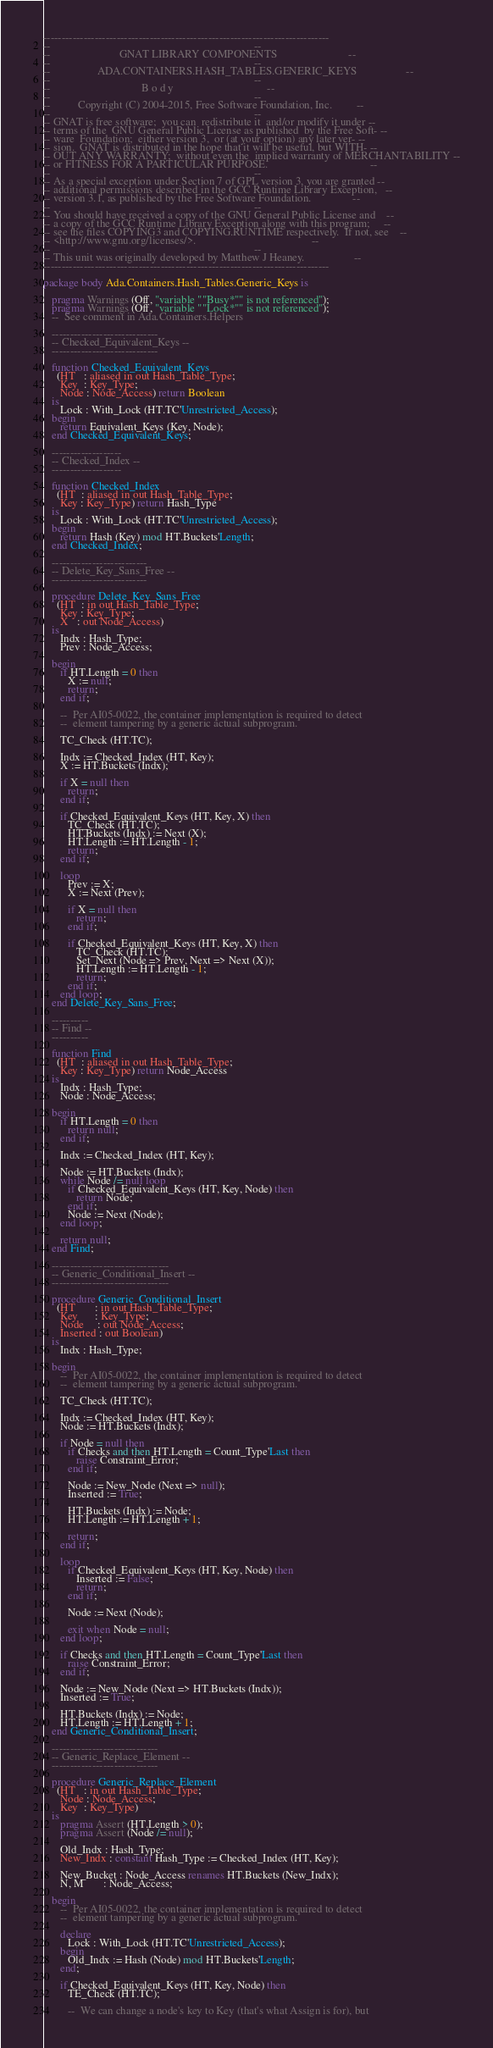Convert code to text. <code><loc_0><loc_0><loc_500><loc_500><_Ada_>------------------------------------------------------------------------------
--                                                                          --
--                         GNAT LIBRARY COMPONENTS                          --
--                                                                          --
--                 ADA.CONTAINERS.HASH_TABLES.GENERIC_KEYS                  --
--                                                                          --
--                                 B o d y                                  --
--                                                                          --
--          Copyright (C) 2004-2015, Free Software Foundation, Inc.         --
--                                                                          --
-- GNAT is free software;  you can  redistribute it  and/or modify it under --
-- terms of the  GNU General Public License as published  by the Free Soft- --
-- ware  Foundation;  either version 3,  or (at your option) any later ver- --
-- sion.  GNAT is distributed in the hope that it will be useful, but WITH- --
-- OUT ANY WARRANTY;  without even the  implied warranty of MERCHANTABILITY --
-- or FITNESS FOR A PARTICULAR PURPOSE.                                     --
--                                                                          --
-- As a special exception under Section 7 of GPL version 3, you are granted --
-- additional permissions described in the GCC Runtime Library Exception,   --
-- version 3.1, as published by the Free Software Foundation.               --
--                                                                          --
-- You should have received a copy of the GNU General Public License and    --
-- a copy of the GCC Runtime Library Exception along with this program;     --
-- see the files COPYING3 and COPYING.RUNTIME respectively.  If not, see    --
-- <http://www.gnu.org/licenses/>.                                          --
--                                                                          --
-- This unit was originally developed by Matthew J Heaney.                  --
------------------------------------------------------------------------------

package body Ada.Containers.Hash_Tables.Generic_Keys is

   pragma Warnings (Off, "variable ""Busy*"" is not referenced");
   pragma Warnings (Off, "variable ""Lock*"" is not referenced");
   --  See comment in Ada.Containers.Helpers

   -----------------------------
   -- Checked_Equivalent_Keys --
   -----------------------------

   function Checked_Equivalent_Keys
     (HT   : aliased in out Hash_Table_Type;
      Key  : Key_Type;
      Node : Node_Access) return Boolean
   is
      Lock : With_Lock (HT.TC'Unrestricted_Access);
   begin
      return Equivalent_Keys (Key, Node);
   end Checked_Equivalent_Keys;

   -------------------
   -- Checked_Index --
   -------------------

   function Checked_Index
     (HT  : aliased in out Hash_Table_Type;
      Key : Key_Type) return Hash_Type
   is
      Lock : With_Lock (HT.TC'Unrestricted_Access);
   begin
      return Hash (Key) mod HT.Buckets'Length;
   end Checked_Index;

   --------------------------
   -- Delete_Key_Sans_Free --
   --------------------------

   procedure Delete_Key_Sans_Free
     (HT  : in out Hash_Table_Type;
      Key : Key_Type;
      X   : out Node_Access)
   is
      Indx : Hash_Type;
      Prev : Node_Access;

   begin
      if HT.Length = 0 then
         X := null;
         return;
      end if;

      --  Per AI05-0022, the container implementation is required to detect
      --  element tampering by a generic actual subprogram.

      TC_Check (HT.TC);

      Indx := Checked_Index (HT, Key);
      X := HT.Buckets (Indx);

      if X = null then
         return;
      end if;

      if Checked_Equivalent_Keys (HT, Key, X) then
         TC_Check (HT.TC);
         HT.Buckets (Indx) := Next (X);
         HT.Length := HT.Length - 1;
         return;
      end if;

      loop
         Prev := X;
         X := Next (Prev);

         if X = null then
            return;
         end if;

         if Checked_Equivalent_Keys (HT, Key, X) then
            TC_Check (HT.TC);
            Set_Next (Node => Prev, Next => Next (X));
            HT.Length := HT.Length - 1;
            return;
         end if;
      end loop;
   end Delete_Key_Sans_Free;

   ----------
   -- Find --
   ----------

   function Find
     (HT  : aliased in out Hash_Table_Type;
      Key : Key_Type) return Node_Access
   is
      Indx : Hash_Type;
      Node : Node_Access;

   begin
      if HT.Length = 0 then
         return null;
      end if;

      Indx := Checked_Index (HT, Key);

      Node := HT.Buckets (Indx);
      while Node /= null loop
         if Checked_Equivalent_Keys (HT, Key, Node) then
            return Node;
         end if;
         Node := Next (Node);
      end loop;

      return null;
   end Find;

   --------------------------------
   -- Generic_Conditional_Insert --
   --------------------------------

   procedure Generic_Conditional_Insert
     (HT       : in out Hash_Table_Type;
      Key      : Key_Type;
      Node     : out Node_Access;
      Inserted : out Boolean)
   is
      Indx : Hash_Type;

   begin
      --  Per AI05-0022, the container implementation is required to detect
      --  element tampering by a generic actual subprogram.

      TC_Check (HT.TC);

      Indx := Checked_Index (HT, Key);
      Node := HT.Buckets (Indx);

      if Node = null then
         if Checks and then HT.Length = Count_Type'Last then
            raise Constraint_Error;
         end if;

         Node := New_Node (Next => null);
         Inserted := True;

         HT.Buckets (Indx) := Node;
         HT.Length := HT.Length + 1;

         return;
      end if;

      loop
         if Checked_Equivalent_Keys (HT, Key, Node) then
            Inserted := False;
            return;
         end if;

         Node := Next (Node);

         exit when Node = null;
      end loop;

      if Checks and then HT.Length = Count_Type'Last then
         raise Constraint_Error;
      end if;

      Node := New_Node (Next => HT.Buckets (Indx));
      Inserted := True;

      HT.Buckets (Indx) := Node;
      HT.Length := HT.Length + 1;
   end Generic_Conditional_Insert;

   -----------------------------
   -- Generic_Replace_Element --
   -----------------------------

   procedure Generic_Replace_Element
     (HT   : in out Hash_Table_Type;
      Node : Node_Access;
      Key  : Key_Type)
   is
      pragma Assert (HT.Length > 0);
      pragma Assert (Node /= null);

      Old_Indx : Hash_Type;
      New_Indx : constant Hash_Type := Checked_Index (HT, Key);

      New_Bucket : Node_Access renames HT.Buckets (New_Indx);
      N, M       : Node_Access;

   begin
      --  Per AI05-0022, the container implementation is required to detect
      --  element tampering by a generic actual subprogram.

      declare
         Lock : With_Lock (HT.TC'Unrestricted_Access);
      begin
         Old_Indx := Hash (Node) mod HT.Buckets'Length;
      end;

      if Checked_Equivalent_Keys (HT, Key, Node) then
         TE_Check (HT.TC);

         --  We can change a node's key to Key (that's what Assign is for), but</code> 